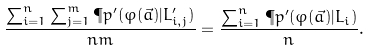Convert formula to latex. <formula><loc_0><loc_0><loc_500><loc_500>\frac { \sum _ { i = 1 } ^ { n } \sum _ { j = 1 } ^ { m } \P p ^ { \prime } ( \varphi ( \vec { a } ) | L ^ { \prime } _ { i , j } ) } { n m } = \frac { \sum _ { i = 1 } ^ { n } \P p ^ { \prime } ( \varphi ( \vec { a } ) | L _ { i } ) } { n } .</formula> 